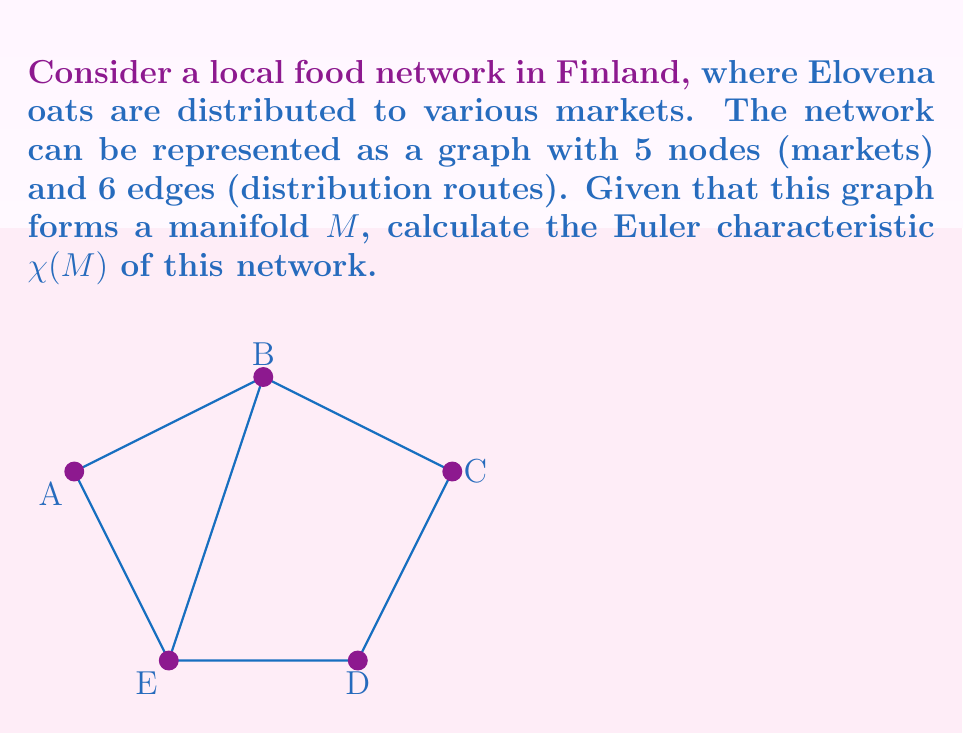Solve this math problem. To calculate the Euler characteristic $\chi(M)$ of the manifold representing our local food network, we need to use the formula:

$$\chi(M) = V - E + F$$

Where:
$V$ = number of vertices (nodes/markets)
$E$ = number of edges (distribution routes)
$F$ = number of faces (regions enclosed by edges)

Step 1: Count the number of vertices (V)
From the given information, we have 5 markets, so $V = 5$

Step 2: Count the number of edges (E)
We are given that there are 6 distribution routes, so $E = 6$

Step 3: Count the number of faces (F)
To count the faces, we need to identify the regions enclosed by the edges, including the outer region:
- Inner triangle (B-E-A)
- Quadrilateral (B-C-D-E)
- Outer region

Therefore, $F = 3$

Step 4: Apply the Euler characteristic formula
$$\chi(M) = V - E + F$$
$$\chi(M) = 5 - 6 + 3$$
$$\chi(M) = 2$$

The Euler characteristic of this network manifold is 2.
Answer: $\chi(M) = 2$ 